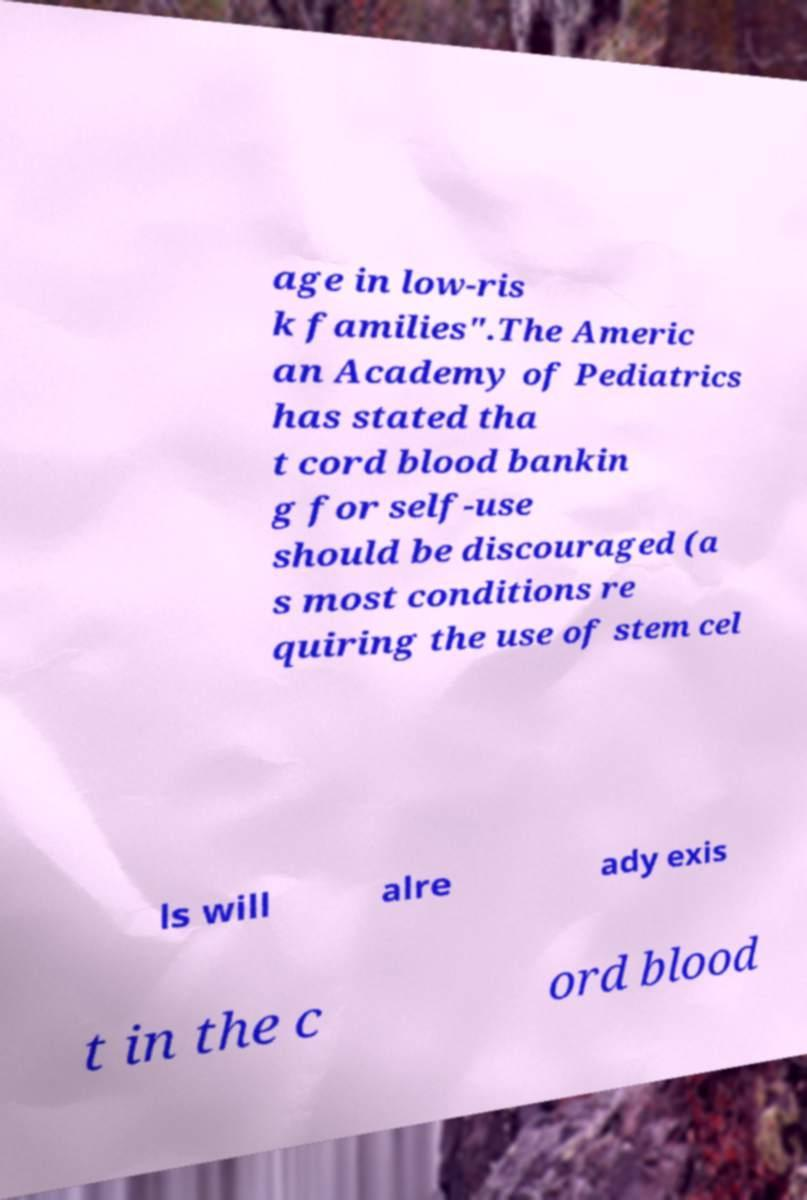There's text embedded in this image that I need extracted. Can you transcribe it verbatim? age in low-ris k families".The Americ an Academy of Pediatrics has stated tha t cord blood bankin g for self-use should be discouraged (a s most conditions re quiring the use of stem cel ls will alre ady exis t in the c ord blood 